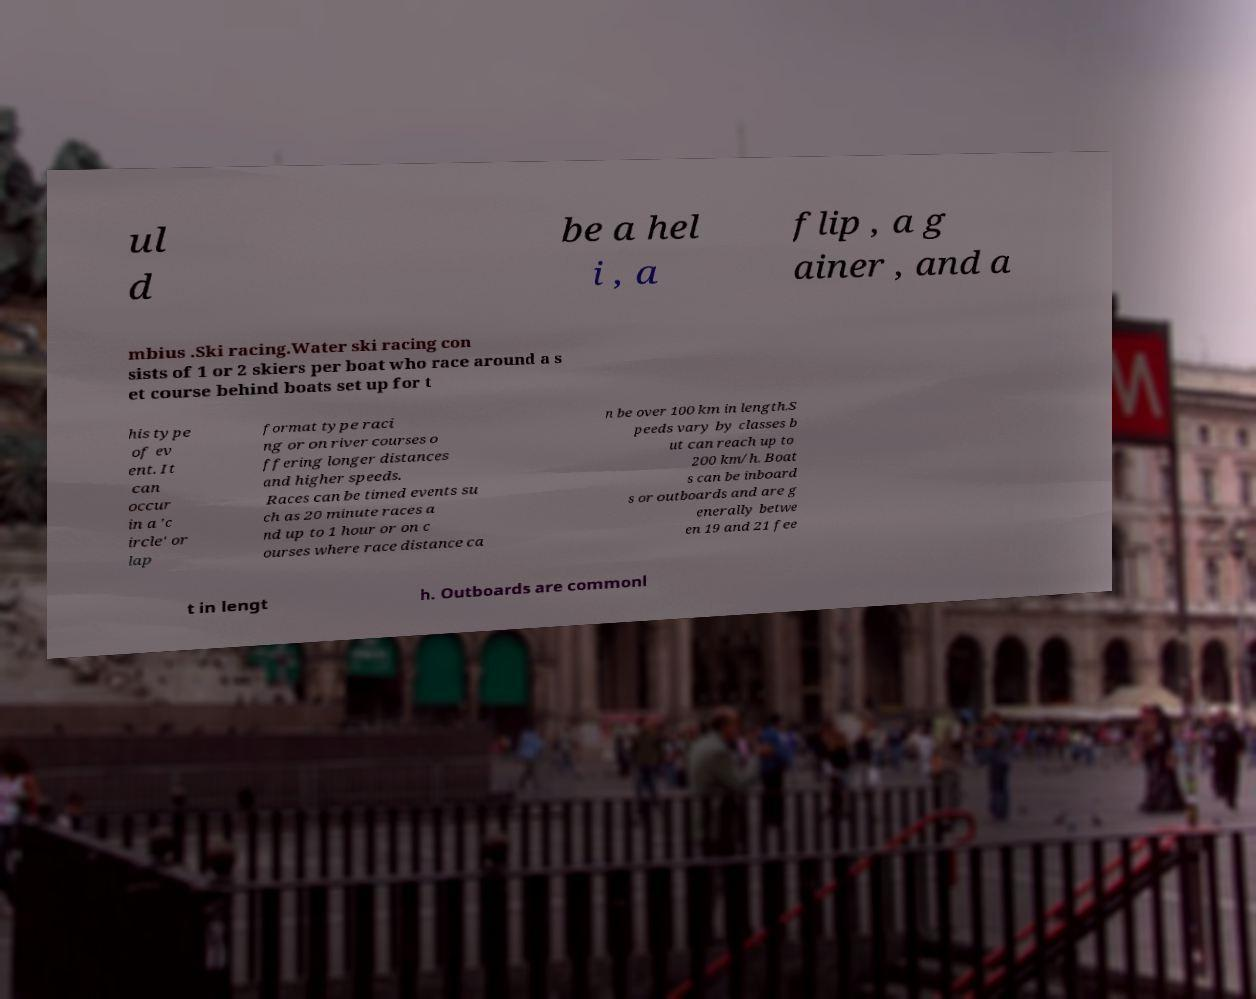Please read and relay the text visible in this image. What does it say? ul d be a hel i , a flip , a g ainer , and a mbius .Ski racing.Water ski racing con sists of 1 or 2 skiers per boat who race around a s et course behind boats set up for t his type of ev ent. It can occur in a 'c ircle' or lap format type raci ng or on river courses o ffering longer distances and higher speeds. Races can be timed events su ch as 20 minute races a nd up to 1 hour or on c ourses where race distance ca n be over 100 km in length.S peeds vary by classes b ut can reach up to 200 km/h. Boat s can be inboard s or outboards and are g enerally betwe en 19 and 21 fee t in lengt h. Outboards are commonl 